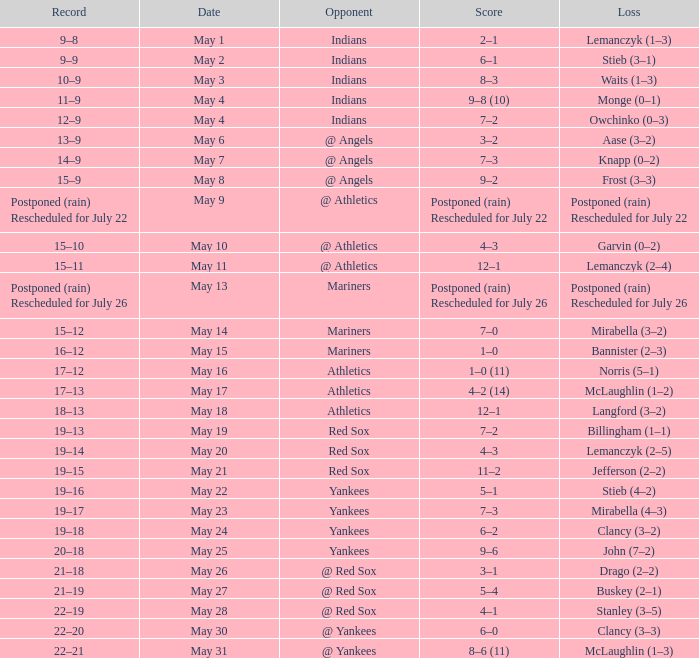Name the loss on may 22 Stieb (4–2). 